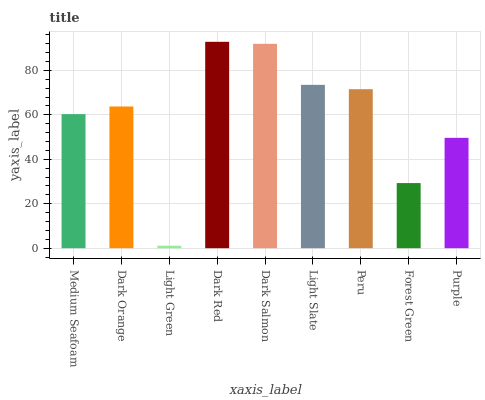Is Light Green the minimum?
Answer yes or no. Yes. Is Dark Red the maximum?
Answer yes or no. Yes. Is Dark Orange the minimum?
Answer yes or no. No. Is Dark Orange the maximum?
Answer yes or no. No. Is Dark Orange greater than Medium Seafoam?
Answer yes or no. Yes. Is Medium Seafoam less than Dark Orange?
Answer yes or no. Yes. Is Medium Seafoam greater than Dark Orange?
Answer yes or no. No. Is Dark Orange less than Medium Seafoam?
Answer yes or no. No. Is Dark Orange the high median?
Answer yes or no. Yes. Is Dark Orange the low median?
Answer yes or no. Yes. Is Light Green the high median?
Answer yes or no. No. Is Light Slate the low median?
Answer yes or no. No. 